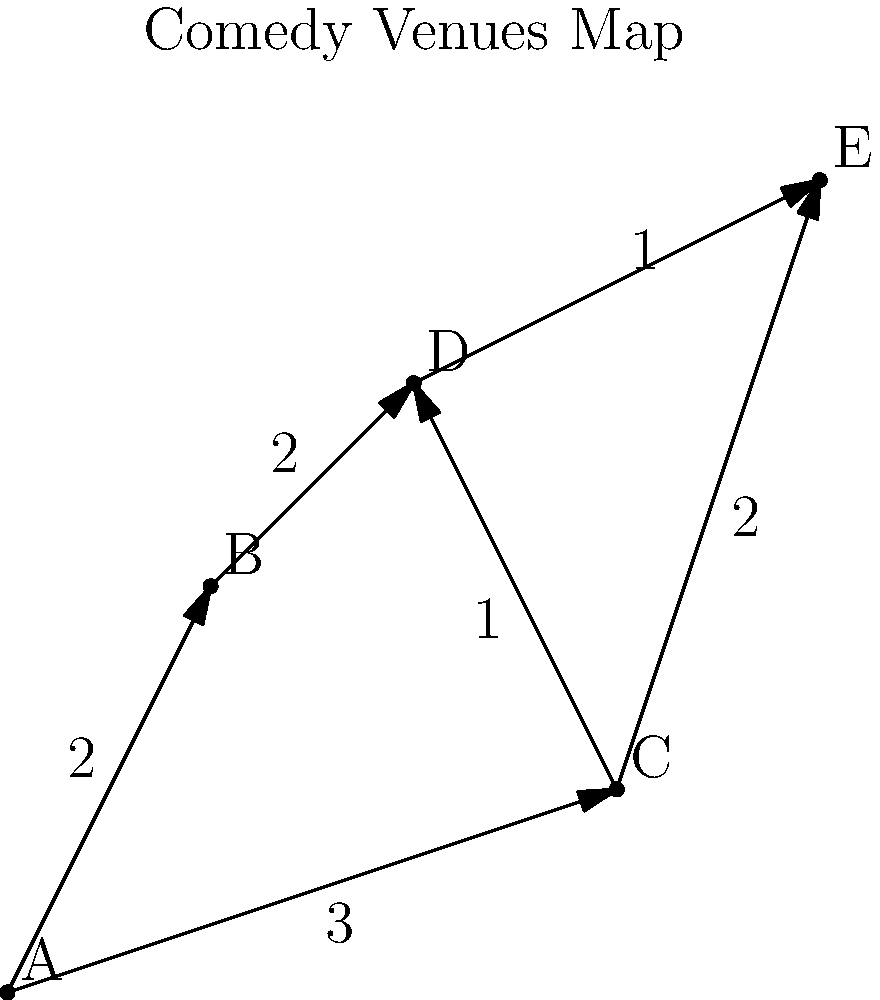As a rising stand-up comedian, you've been asked to perform at multiple venues in one night. The map shows five comedy clubs (A, B, C, D, E) in the city, with travel times (in hours) between connected venues. Starting from venue A, what's the shortest time to visit all venues and end at venue E? To find the shortest path visiting all venues from A to E, we'll use a step-by-step approach:

1) First, list all possible paths from A to E visiting all venues:
   A-B-D-C-E
   A-B-D-E-C
   A-C-D-B-E
   A-C-E-D-B (invalid, as B is not connected to E)

2) Calculate the total time for each valid path:

   A-B-D-C-E:
   A to B: 2 hours
   B to D: 2 hours
   D to C: 1 hour
   C to E: 2 hours
   Total: 2 + 2 + 1 + 2 = 7 hours

   A-B-D-E-C:
   A to B: 2 hours
   B to D: 2 hours
   D to E: 1 hour
   E to C: 2 hours
   Total: 2 + 2 + 1 + 2 = 7 hours

   A-C-D-B-E:
   A to C: 3 hours
   C to D: 1 hour
   D to B: 2 hours
   B to E: Not directly connected

3) The path A-C-D-B-E is not possible as there's no direct connection from B to E.

4) Both A-B-D-C-E and A-B-D-E-C take 7 hours, which is the shortest time to visit all venues.
Answer: 7 hours 